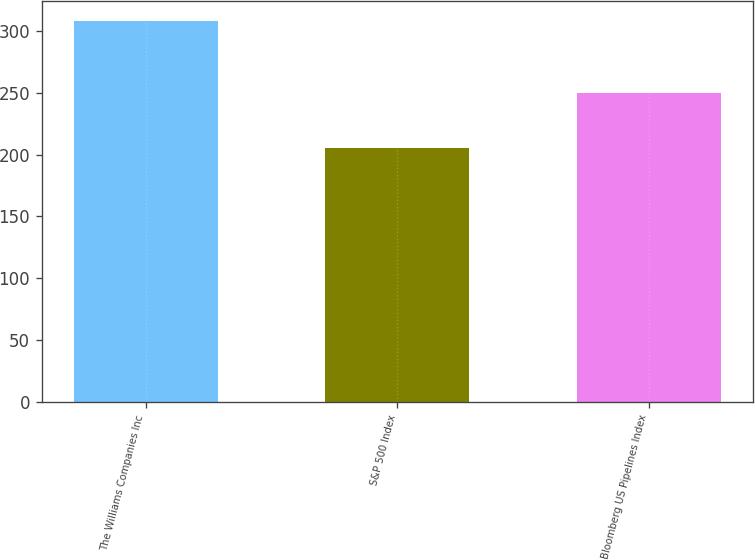Convert chart to OTSL. <chart><loc_0><loc_0><loc_500><loc_500><bar_chart><fcel>The Williams Companies Inc<fcel>S&P 500 Index<fcel>Bloomberg US Pipelines Index<nl><fcel>308.4<fcel>205<fcel>250.1<nl></chart> 